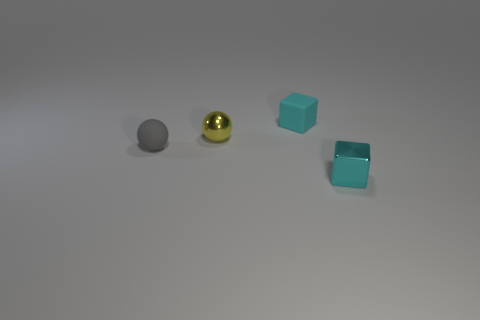What number of large things are brown matte things or matte things?
Ensure brevity in your answer.  0. What size is the matte block?
Make the answer very short. Small. What number of gray objects are either matte objects or cubes?
Your response must be concise. 1. What number of blue metal things are there?
Your response must be concise. 0. What is the size of the cube on the left side of the cyan shiny block?
Give a very brief answer. Small. Is the size of the cyan metallic block the same as the shiny sphere?
Make the answer very short. Yes. How many objects are tiny yellow metallic spheres or small metal things that are behind the small cyan metallic object?
Your answer should be compact. 1. What is the material of the yellow object?
Your answer should be very brief. Metal. Are there any other things of the same color as the tiny metallic sphere?
Offer a terse response. No. Is the small gray rubber thing the same shape as the yellow thing?
Offer a very short reply. Yes. 